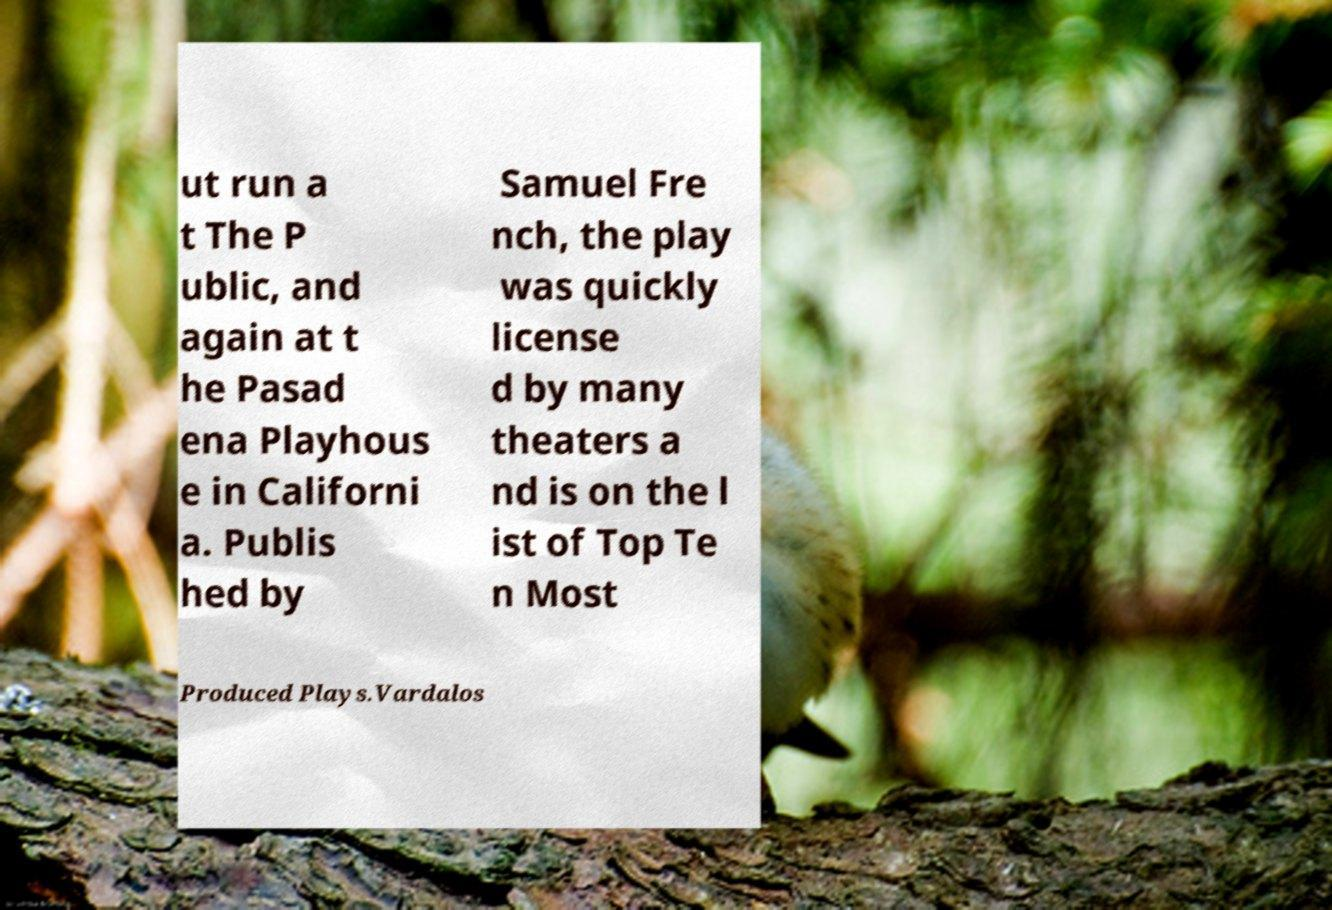Can you read and provide the text displayed in the image?This photo seems to have some interesting text. Can you extract and type it out for me? ut run a t The P ublic, and again at t he Pasad ena Playhous e in Californi a. Publis hed by Samuel Fre nch, the play was quickly license d by many theaters a nd is on the l ist of Top Te n Most Produced Plays.Vardalos 